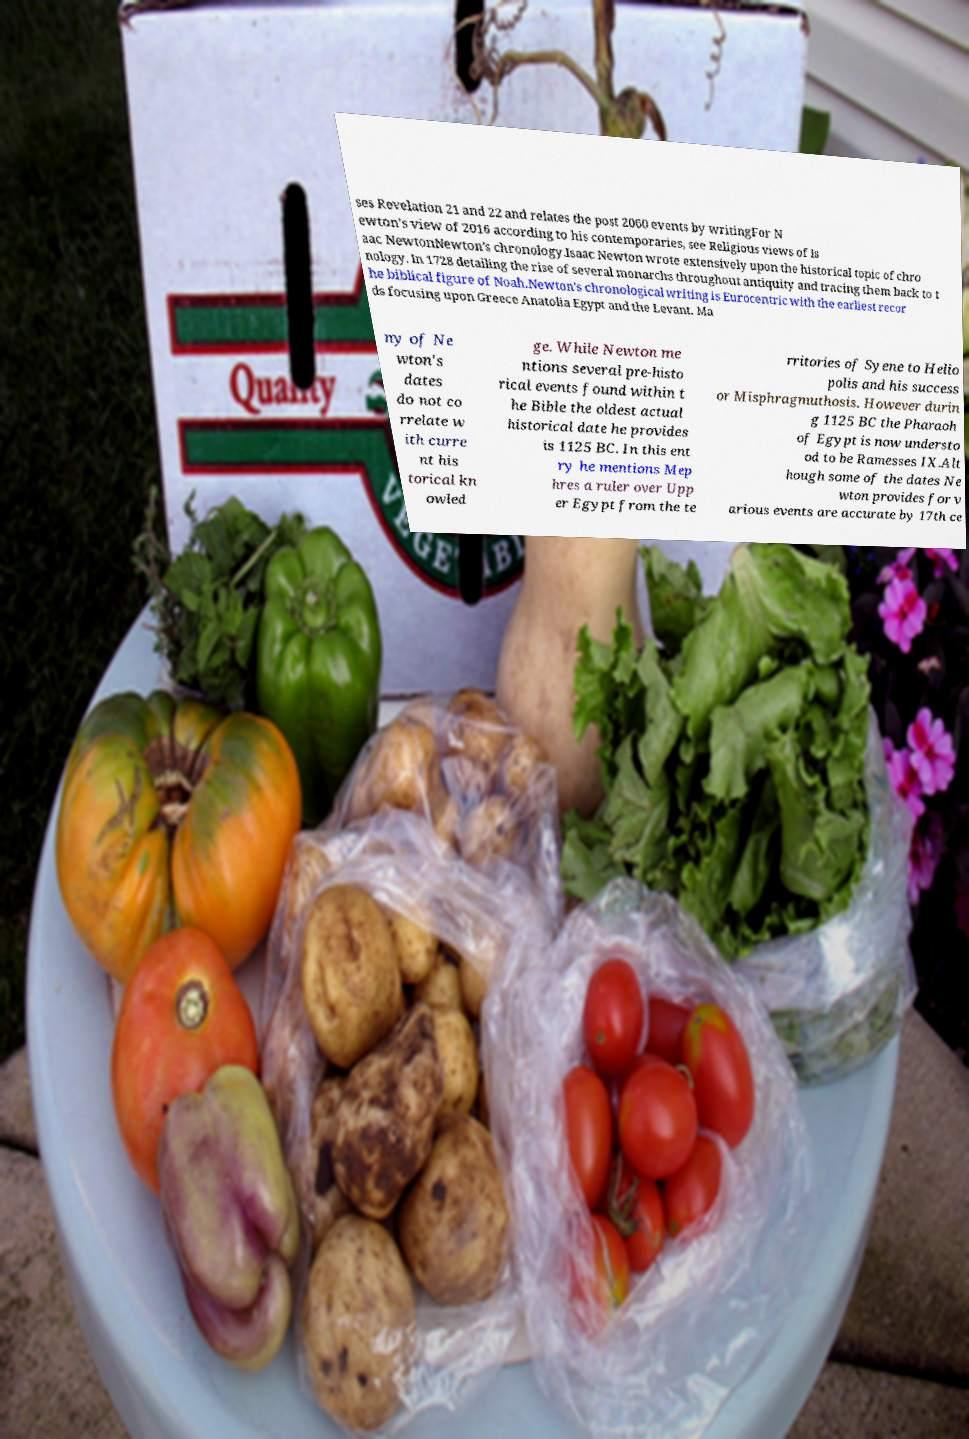Can you accurately transcribe the text from the provided image for me? ses Revelation 21 and 22 and relates the post 2060 events by writingFor N ewton's view of 2016 according to his contemporaries, see Religious views of Is aac NewtonNewton's chronology.Isaac Newton wrote extensively upon the historical topic of chro nology. In 1728 detailing the rise of several monarchs throughout antiquity and tracing them back to t he biblical figure of Noah.Newton's chronological writing is Eurocentric with the earliest recor ds focusing upon Greece Anatolia Egypt and the Levant. Ma ny of Ne wton's dates do not co rrelate w ith curre nt his torical kn owled ge. While Newton me ntions several pre-histo rical events found within t he Bible the oldest actual historical date he provides is 1125 BC. In this ent ry he mentions Mep hres a ruler over Upp er Egypt from the te rritories of Syene to Helio polis and his success or Misphragmuthosis. However durin g 1125 BC the Pharaoh of Egypt is now understo od to be Ramesses IX.Alt hough some of the dates Ne wton provides for v arious events are accurate by 17th ce 